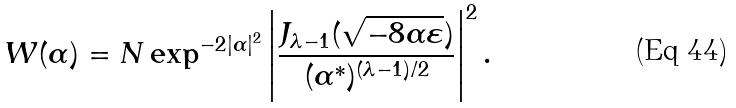<formula> <loc_0><loc_0><loc_500><loc_500>W ( \alpha ) = N \exp ^ { - 2 | \alpha | ^ { 2 } } \left | \frac { J _ { \lambda - 1 } ( \sqrt { - 8 \alpha \varepsilon } ) } { ( \alpha ^ { * } ) ^ { ( \lambda - 1 ) / 2 } } \right | ^ { 2 } .</formula> 